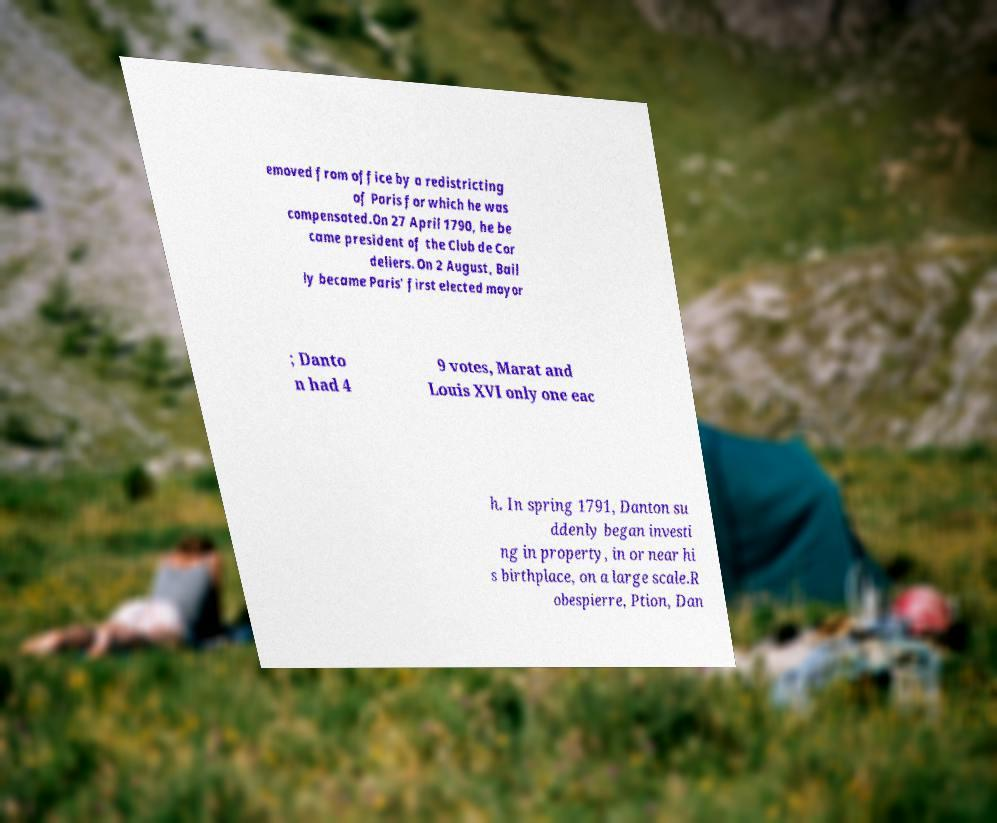There's text embedded in this image that I need extracted. Can you transcribe it verbatim? emoved from office by a redistricting of Paris for which he was compensated.On 27 April 1790, he be came president of the Club de Cor deliers. On 2 August, Bail ly became Paris' first elected mayor ; Danto n had 4 9 votes, Marat and Louis XVI only one eac h. In spring 1791, Danton su ddenly began investi ng in property, in or near hi s birthplace, on a large scale.R obespierre, Ption, Dan 